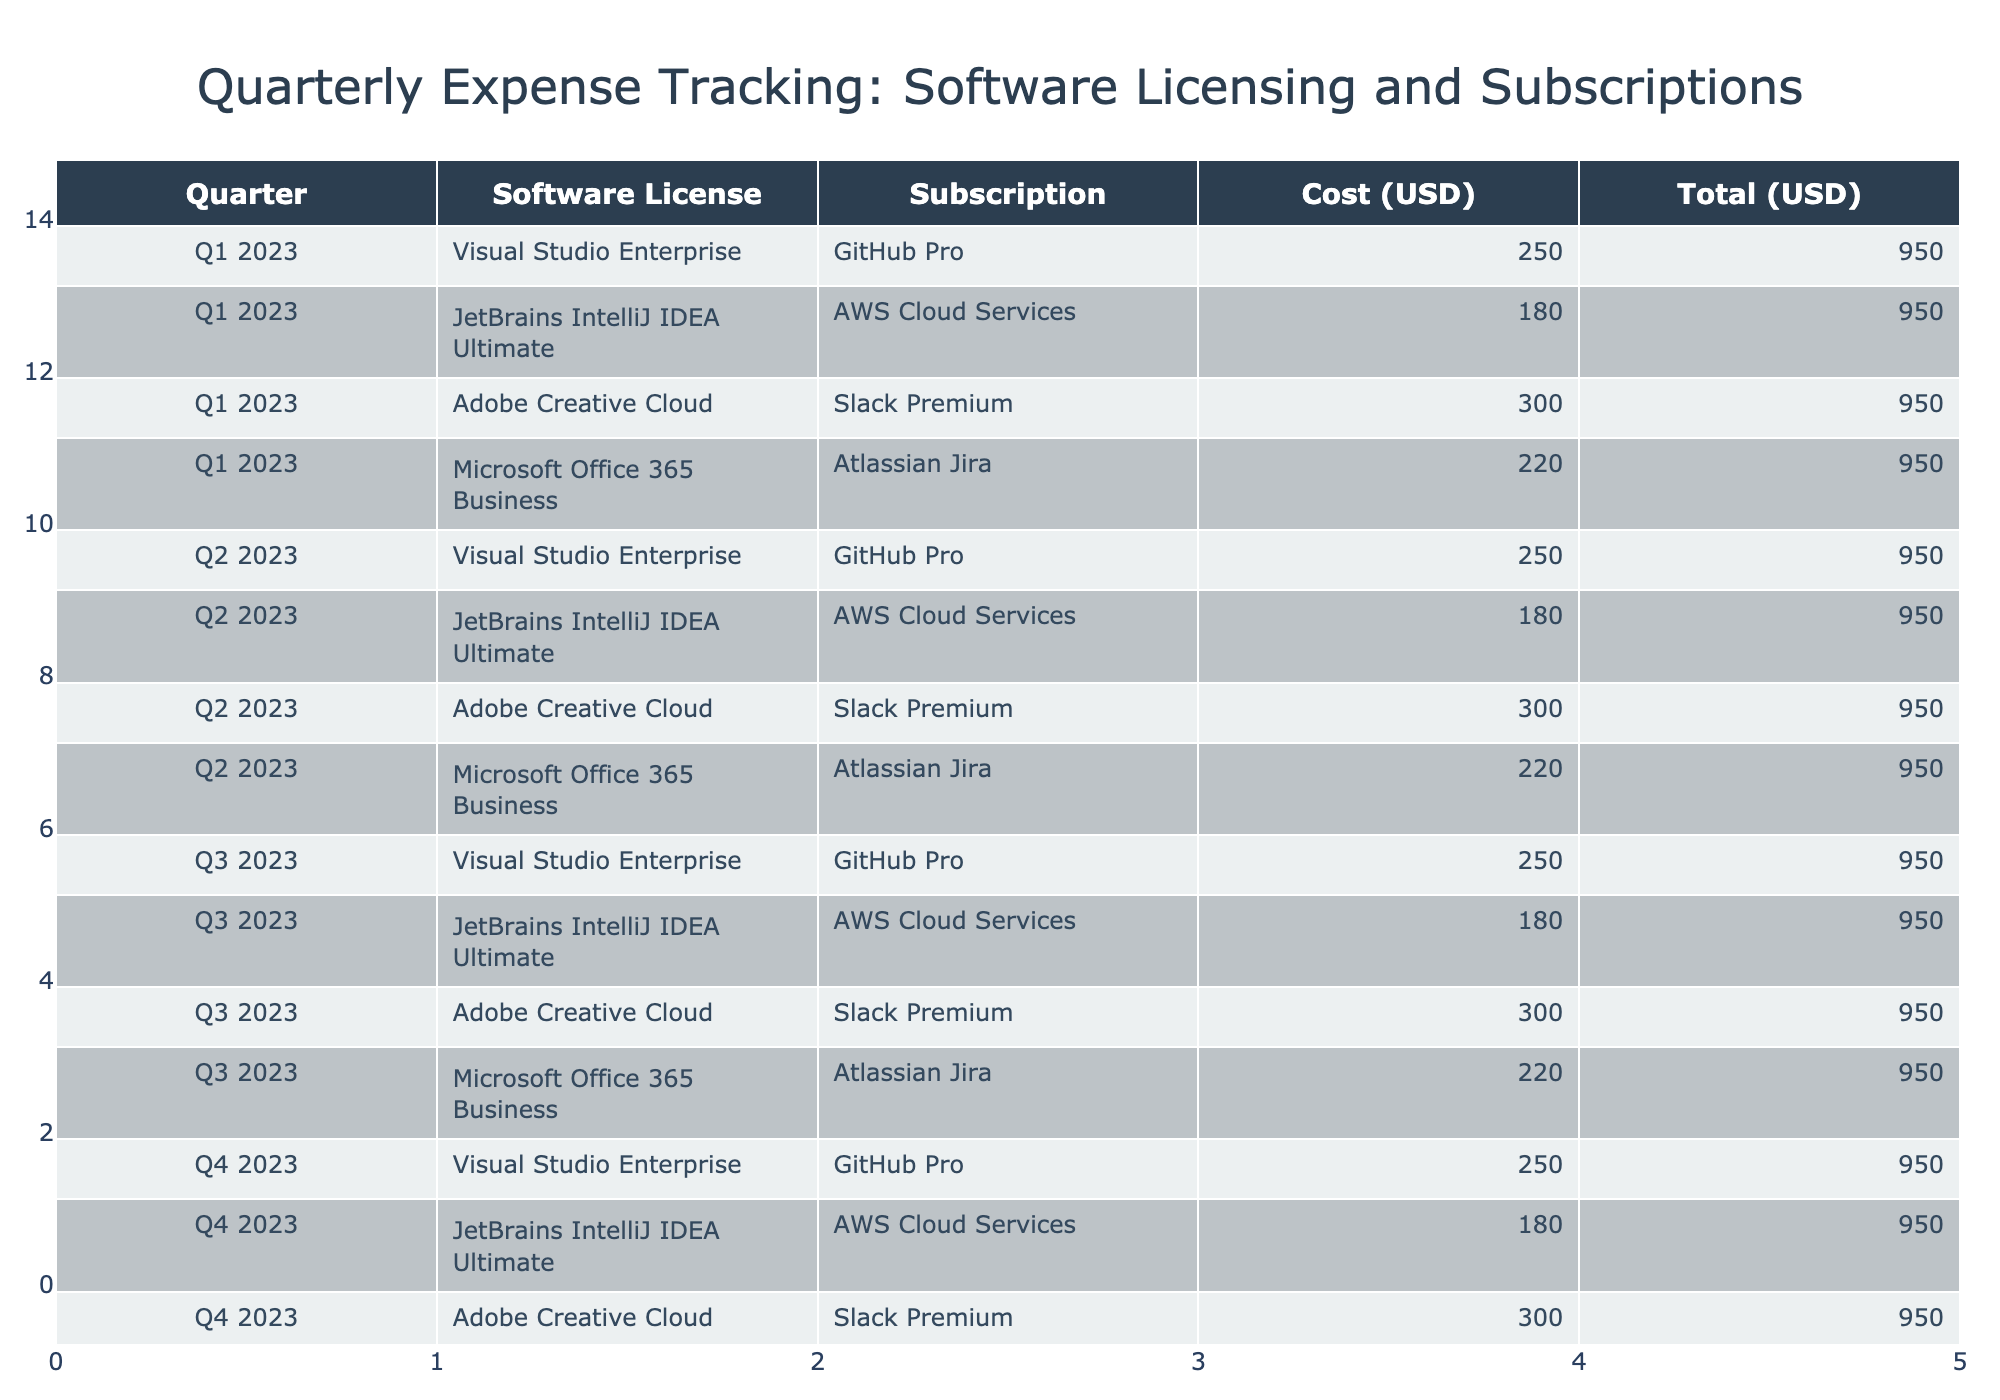What is the total cost for Q1 2023? To find the total cost for Q1 2023, we look at the costs for all entries in that quarter: 250 + 180 + 300 + 220 = 950.
Answer: 950 Which software license had the highest cost in Q2 2023? In Q2 2023, the software license costs are: Visual Studio Enterprise 250, JetBrains IntelliJ IDEA Ultimate 180, Adobe Creative Cloud 300, and Microsoft Office 365 Business 220. The highest is Adobe Creative Cloud at 300.
Answer: Adobe Creative Cloud Is the cost for GitHub Pro consistent across all quarters? The cost for GitHub Pro is 250 for Q1, Q2, Q3, and Q4, so it remains constant throughout the year, making it consistent across all quarters.
Answer: Yes What is the average cost for subscriptions in Q3 2023? The subscription costs in Q3 2023 are: GitHub Pro 250, AWS Cloud Services 180, Slack Premium 300, and Atlassian Jira 220. The total is 250 + 180 + 300 + 220 = 950; dividing by 4 gives an average of 950/4 = 237.5.
Answer: 237.5 Which quarter had the highest total expenses for software licenses and subscriptions? To find the quarter with the highest total expenses, we sum the costs for each quarter: Q1 950, Q2 950, Q3 950, Q4 950. All quarters have the same total costs of 950, hence there is no highest.
Answer: None (tie) What is the difference in total costs between Q1 and Q2? The total cost for both Q1 and Q2 is the same at 950 each, so the difference is 950 - 950 = 0.
Answer: 0 Did Adobe Creative Cloud cost more than Microsoft Office 365 Business in any quarter? Comparing costs in all quarters, Adobe Creative Cloud costs 300, while Microsoft Office 365 Business costs 220. Adobe Creative Cloud is more expensive in each quarter.
Answer: Yes What was the cost for AWS Cloud Services in Q4 2023? The AWS Cloud Services cost in Q4 2023 is clearly listed in the table as 180.
Answer: 180 How many total distinct software licenses are listed in the table? The distinct software licenses are Visual Studio Enterprise, JetBrains IntelliJ IDEA Ultimate, Adobe Creative Cloud, and Microsoft Office 365 Business, which gives us 4 distinct licenses.
Answer: 4 